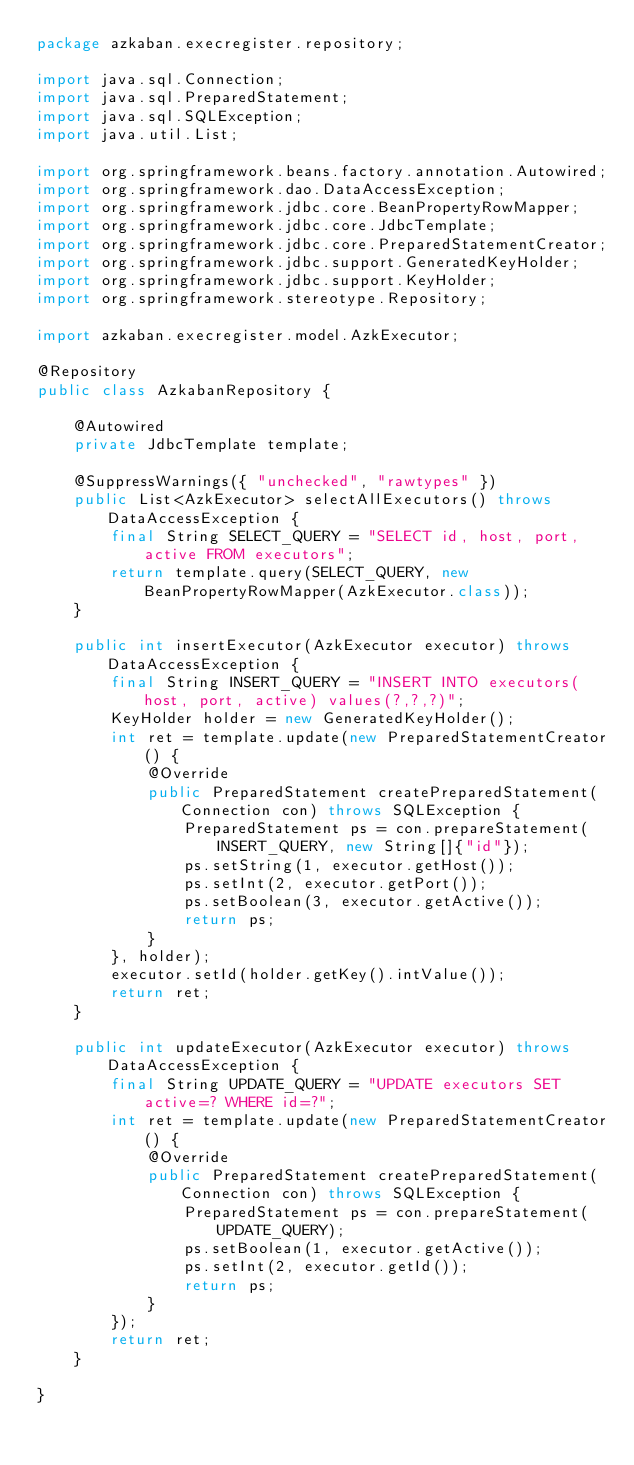<code> <loc_0><loc_0><loc_500><loc_500><_Java_>package azkaban.execregister.repository;

import java.sql.Connection;
import java.sql.PreparedStatement;
import java.sql.SQLException;
import java.util.List;

import org.springframework.beans.factory.annotation.Autowired;
import org.springframework.dao.DataAccessException;
import org.springframework.jdbc.core.BeanPropertyRowMapper;
import org.springframework.jdbc.core.JdbcTemplate;
import org.springframework.jdbc.core.PreparedStatementCreator;
import org.springframework.jdbc.support.GeneratedKeyHolder;
import org.springframework.jdbc.support.KeyHolder;
import org.springframework.stereotype.Repository;

import azkaban.execregister.model.AzkExecutor;

@Repository
public class AzkabanRepository {

	@Autowired
	private JdbcTemplate template;
	
	@SuppressWarnings({ "unchecked", "rawtypes" })
	public List<AzkExecutor> selectAllExecutors() throws DataAccessException {
		final String SELECT_QUERY = "SELECT id, host, port, active FROM executors";
		return template.query(SELECT_QUERY, new BeanPropertyRowMapper(AzkExecutor.class));
	}
	
	public int insertExecutor(AzkExecutor executor) throws DataAccessException {
		final String INSERT_QUERY = "INSERT INTO executors(host, port, active) values(?,?,?)";
		KeyHolder holder = new GeneratedKeyHolder();
		int ret = template.update(new PreparedStatementCreator() {
			@Override
			public PreparedStatement createPreparedStatement(Connection con) throws SQLException {
				PreparedStatement ps = con.prepareStatement(INSERT_QUERY, new String[]{"id"});
				ps.setString(1, executor.getHost());
				ps.setInt(2, executor.getPort());
				ps.setBoolean(3, executor.getActive());
				return ps;
			}
		}, holder);
		executor.setId(holder.getKey().intValue());
		return ret;
	}
	
	public int updateExecutor(AzkExecutor executor) throws DataAccessException {
		final String UPDATE_QUERY = "UPDATE executors SET active=? WHERE id=?";
		int ret = template.update(new PreparedStatementCreator() {
			@Override
			public PreparedStatement createPreparedStatement(Connection con) throws SQLException {
				PreparedStatement ps = con.prepareStatement(UPDATE_QUERY);
				ps.setBoolean(1, executor.getActive());
				ps.setInt(2, executor.getId());
				return ps;
			}
		});
		return ret;
	}

}
</code> 